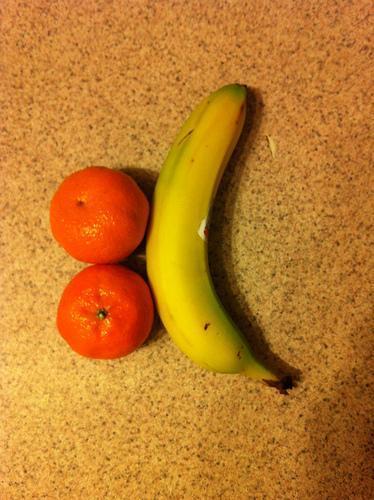How many fruits total?
Give a very brief answer. 3. 